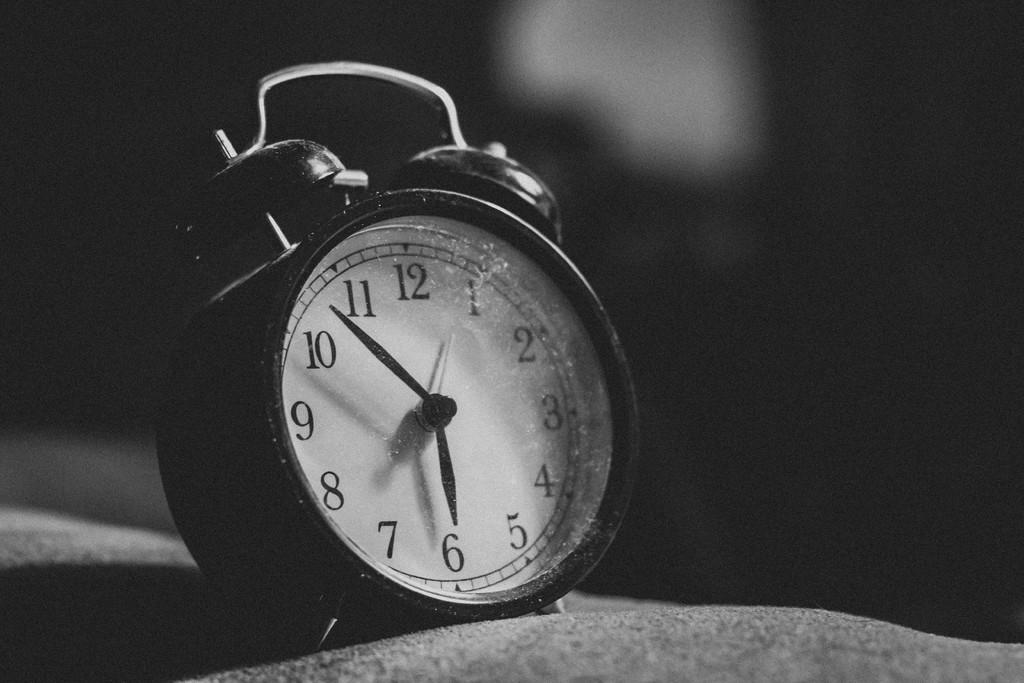<image>
Relay a brief, clear account of the picture shown. An alarm clock displaying the time as 5:53. 